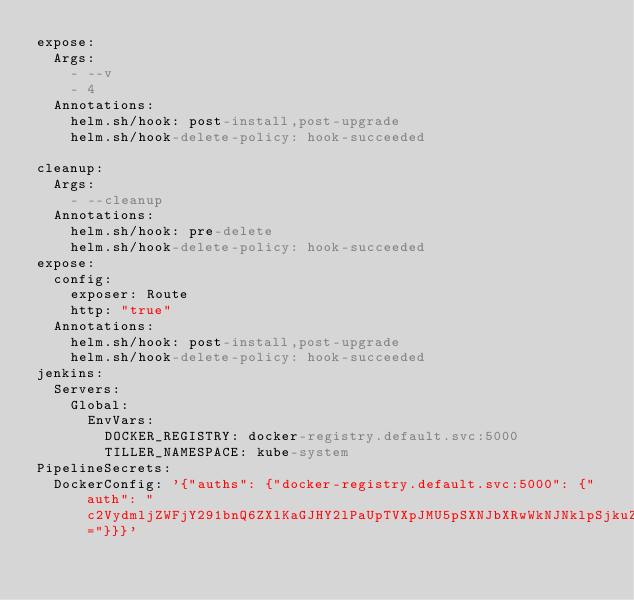Convert code to text. <code><loc_0><loc_0><loc_500><loc_500><_YAML_>expose:
  Args: 
    - --v
    - 4
  Annotations:
    helm.sh/hook: post-install,post-upgrade
    helm.sh/hook-delete-policy: hook-succeeded

cleanup:
  Args: 
    - --cleanup
  Annotations:
    helm.sh/hook: pre-delete
    helm.sh/hook-delete-policy: hook-succeeded
expose:
  config:
    exposer: Route
    http: "true"
  Annotations:
    helm.sh/hook: post-install,post-upgrade
    helm.sh/hook-delete-policy: hook-succeeded
jenkins:
  Servers:
    Global:
      EnvVars:
        DOCKER_REGISTRY: docker-registry.default.svc:5000
        TILLER_NAMESPACE: kube-system
PipelineSecrets:
  DockerConfig: '{"auths": {"docker-registry.default.svc:5000": {"auth": "c2VydmljZWFjY291bnQ6ZXlKaGJHY2lPaUpTVXpJMU5pSXNJbXRwWkNJNklpSjkuZXlKcGMzTWlPaUpyZFdKbGNtNWxkR1Z6TDNObGNuWnBZMlZoWTJOdmRXNTBJaXdpYTNWaVpYSnVaWFJsY3k1cGJ5OXpaWEoyYVdObFlXTmpiM1Z1ZEM5dVlXMWxjM0JoWTJVaU9pSnFlQ0lzSW10MVltVnlibVYwWlhNdWFXOHZjMlZ5ZG1salpXRmpZMjkxYm5RdmMyVmpjbVYwTG01aGJXVWlPaUpxWlc1cmFXNXpMWGd0Y21WbmFYTjBjbmt0ZEc5clpXNHRibXgzTkRVaUxDSnJkV0psY201bGRHVnpMbWx2TDNObGNuWnBZMlZoWTJOdmRXNTBMM05sY25acFkyVXRZV05qYjNWdWRDNXVZVzFsSWpvaWFtVnVhMmx1Y3kxNExYSmxaMmx6ZEhKNUlpd2lhM1ZpWlhKdVpYUmxjeTVwYnk5elpYSjJhV05sWVdOamIzVnVkQzl6WlhKMmFXTmxMV0ZqWTI5MWJuUXVkV2xrSWpvaU5HUXdaV1kxT0RBdFpqUmlOUzB4TVdVNExUa3pZbVV0TURBMU1EVTJPVEF6TmpnNElpd2ljM1ZpSWpvaWMzbHpkR1Z0T25ObGNuWnBZMlZoWTJOdmRXNTBPbXA0T21wbGJtdHBibk10ZUMxeVpXZHBjM1J5ZVNKOS5wYmtkMU13SnhibmxCdVM1am0wT0ZVOE5LQjE0dWwwTEt0TGZ3SkE2a0lLTXVPS2w0VGNiTW83ODZIaGxBd3JfekxWdlRONE1zd1QxU1ZIT3lfQTJTTFo0Q0ZuaUY5RmFfOThPX2JlTjZVMXhYdVViZjMzcFJ4Q1lTaUNrNjZXcmc2NThFQkFCX3pvTlBzYjFyQ1dmWWpMRTN3VUNUcUYyNkhWcUxHVUZLdk1fNnYyUEJRekNBS2tVb2ptRmpuS3Q2SzdTeXVLSHFBb3VlYzNhWG5lUFY2eEJZMWpyaGN1NVFuaU9jN0hUVGlEWWhNX2dNdHA3LUs1QUd1SHZrbG02M3paRTA5UVItaVJ5Nks5aXZSMzFWcVJaY3Vaem1MZjc2RExEcE40TGxUTWF3T01pNHNOd3UyT1BYZEpzVTZmMEtEXzFsS0RKeE9pcVRwY19jSWY2NGc="}}}'
</code> 